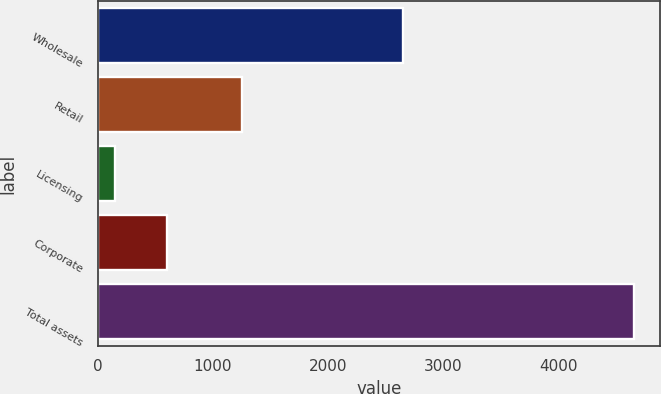<chart> <loc_0><loc_0><loc_500><loc_500><bar_chart><fcel>Wholesale<fcel>Retail<fcel>Licensing<fcel>Corporate<fcel>Total assets<nl><fcel>2650<fcel>1255.6<fcel>155.7<fcel>605.02<fcel>4648.9<nl></chart> 